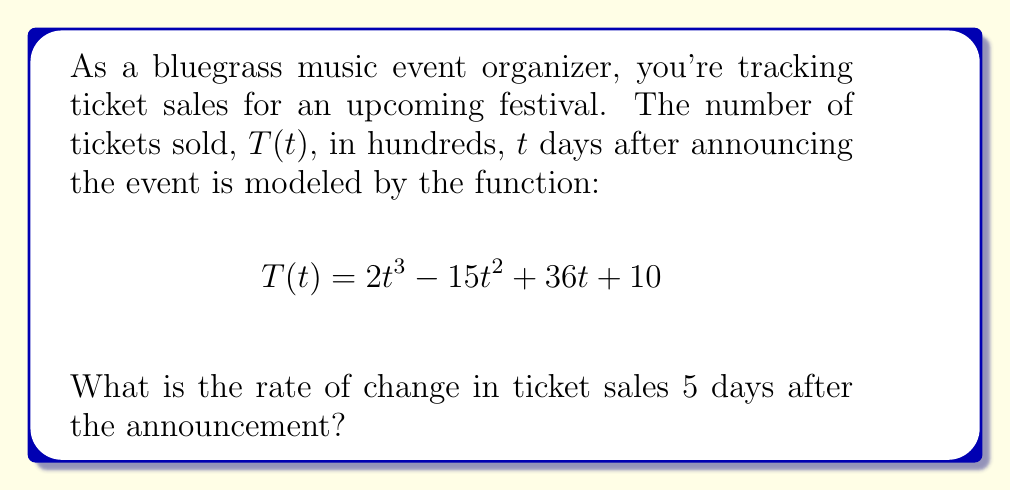Can you solve this math problem? To find the rate of change in ticket sales at a specific point in time, we need to find the derivative of the ticket sales function and evaluate it at the given time.

1. First, let's find the derivative of $T(t)$ with respect to $t$:

   $$\frac{d}{dt}T(t) = \frac{d}{dt}(2t^3 - 15t^2 + 36t + 10)$$
   $$T'(t) = 6t^2 - 30t + 36$$

   This derivative represents the instantaneous rate of change of ticket sales at any given time $t$.

2. Now, we need to evaluate this derivative at $t = 5$ days:

   $$T'(5) = 6(5)^2 - 30(5) + 36$$
   $$= 6(25) - 150 + 36$$
   $$= 150 - 150 + 36$$
   $$= 36$$

3. Interpret the result:
   The rate of change is 36 hundred tickets per day, or 3,600 tickets per day.
Answer: The rate of change in ticket sales 5 days after the announcement is 3,600 tickets per day. 